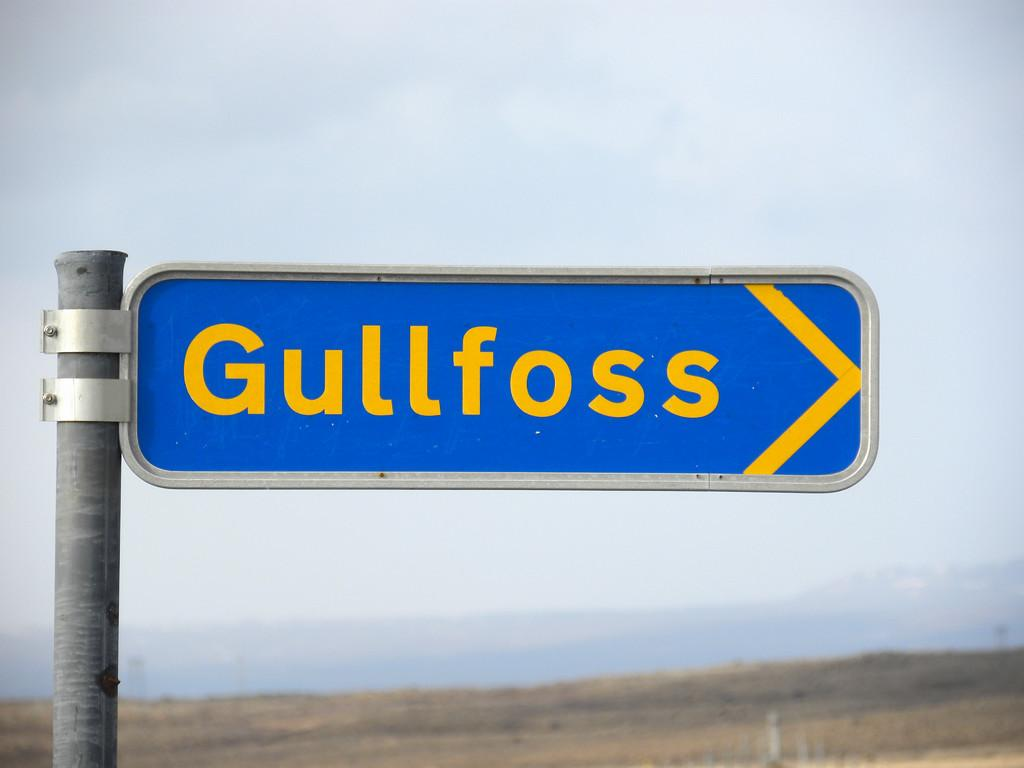<image>
Provide a brief description of the given image. A blue and yellow road sign reading "Gullfoss." 